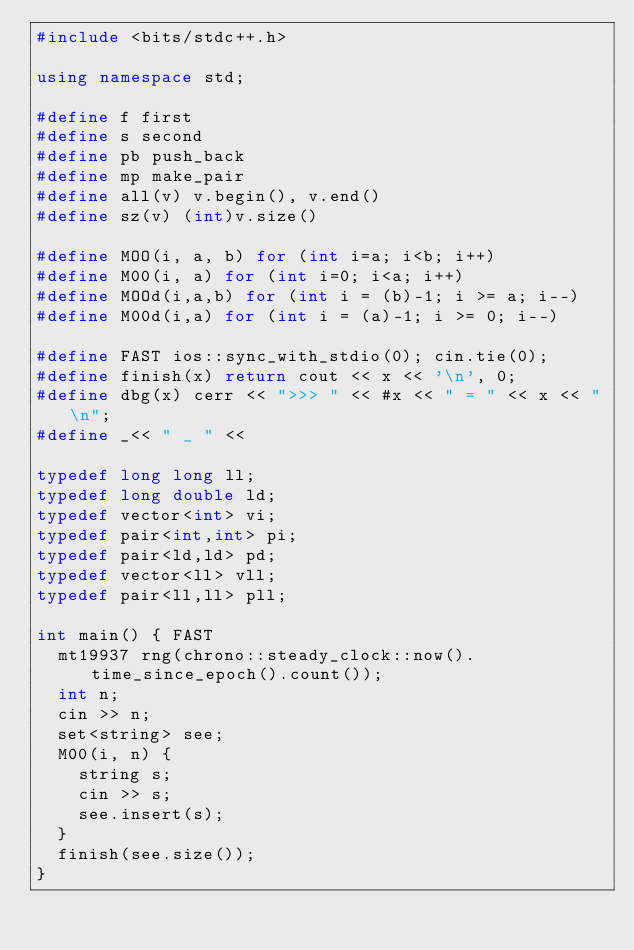Convert code to text. <code><loc_0><loc_0><loc_500><loc_500><_C++_>#include <bits/stdc++.h>

using namespace std;

#define f first
#define s second
#define pb push_back
#define mp make_pair
#define all(v) v.begin(), v.end()
#define sz(v) (int)v.size()

#define MOO(i, a, b) for (int i=a; i<b; i++)
#define M00(i, a) for (int i=0; i<a; i++)
#define MOOd(i,a,b) for (int i = (b)-1; i >= a; i--)
#define M00d(i,a) for (int i = (a)-1; i >= 0; i--)

#define FAST ios::sync_with_stdio(0); cin.tie(0);
#define finish(x) return cout << x << '\n', 0;
#define dbg(x) cerr << ">>> " << #x << " = " << x << "\n";
#define _<< " _ " <<

typedef long long ll;
typedef long double ld;
typedef vector<int> vi;
typedef pair<int,int> pi;
typedef pair<ld,ld> pd;
typedef vector<ll> vll;
typedef pair<ll,ll> pll;

int main() { FAST
	mt19937 rng(chrono::steady_clock::now().time_since_epoch().count());
	int n;
	cin >> n;
	set<string> see;
	M00(i, n) {
		string s;
		cin >> s;
		see.insert(s);
	}
	finish(see.size());
}
</code> 